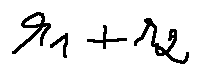<formula> <loc_0><loc_0><loc_500><loc_500>r _ { 1 } + r _ { 2 }</formula> 